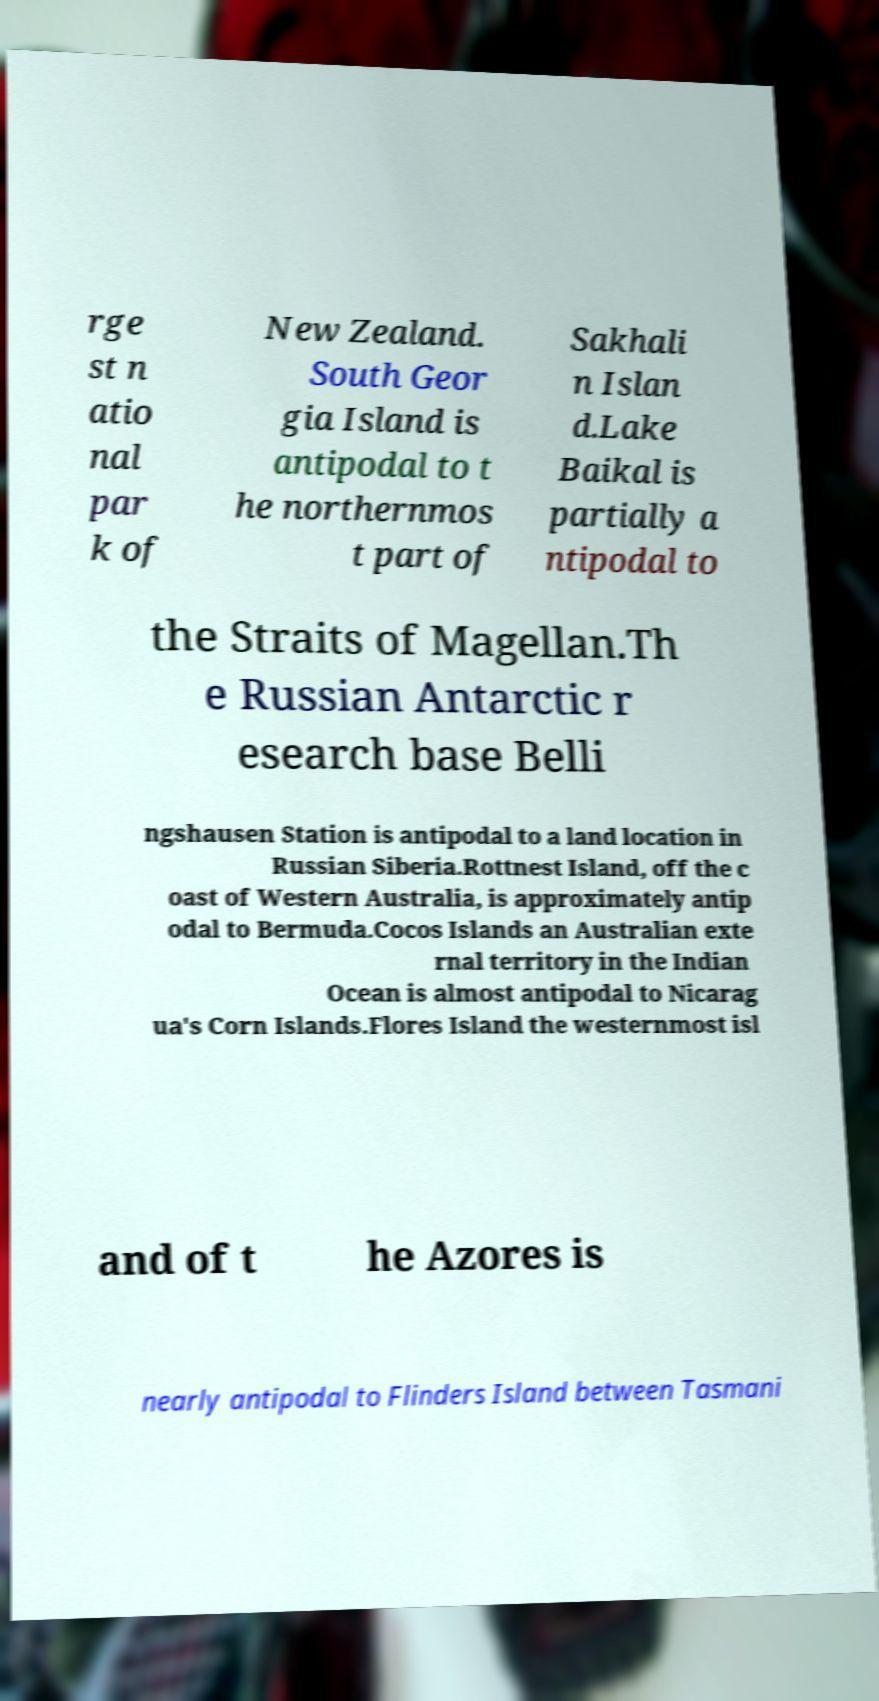What messages or text are displayed in this image? I need them in a readable, typed format. rge st n atio nal par k of New Zealand. South Geor gia Island is antipodal to t he northernmos t part of Sakhali n Islan d.Lake Baikal is partially a ntipodal to the Straits of Magellan.Th e Russian Antarctic r esearch base Belli ngshausen Station is antipodal to a land location in Russian Siberia.Rottnest Island, off the c oast of Western Australia, is approximately antip odal to Bermuda.Cocos Islands an Australian exte rnal territory in the Indian Ocean is almost antipodal to Nicarag ua's Corn Islands.Flores Island the westernmost isl and of t he Azores is nearly antipodal to Flinders Island between Tasmani 